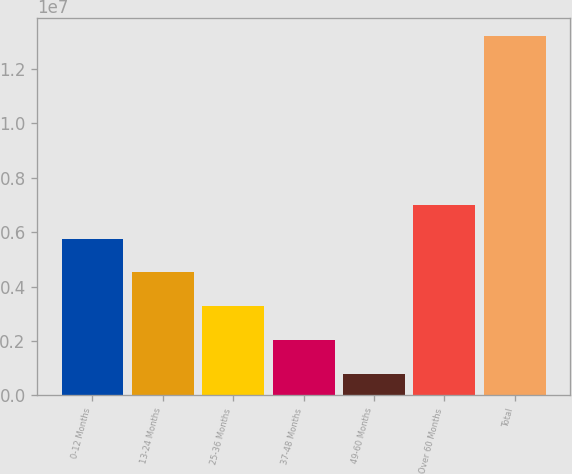<chart> <loc_0><loc_0><loc_500><loc_500><bar_chart><fcel>0-12 Months<fcel>13-24 Months<fcel>25-36 Months<fcel>37-48 Months<fcel>49-60 Months<fcel>Over 60 Months<fcel>Total<nl><fcel>5.76078e+06<fcel>4.5215e+06<fcel>3.28223e+06<fcel>2.04295e+06<fcel>803678<fcel>7.00005e+06<fcel>1.31964e+07<nl></chart> 